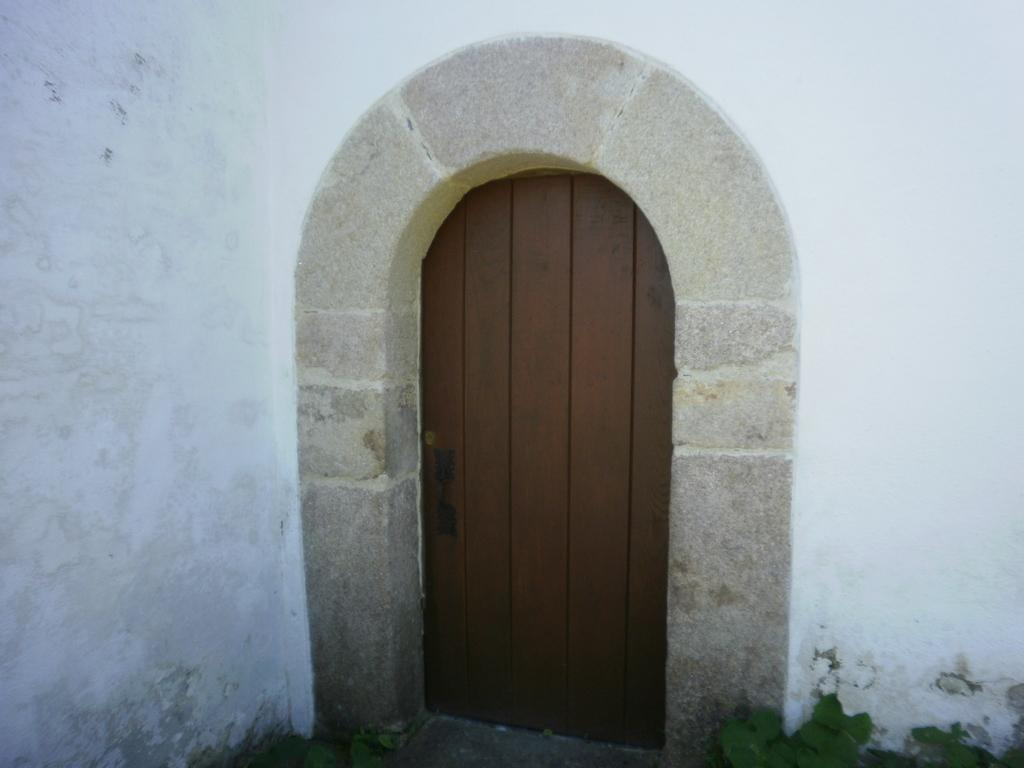What type of structure is visible in the image? There is a house in the image. What can be seen on the house in the image? The door of the house is brown in color. What type of toothbrush is hanging on the door of the house in the image? There is no toothbrush visible in the image; only the house and the brown door are present. 